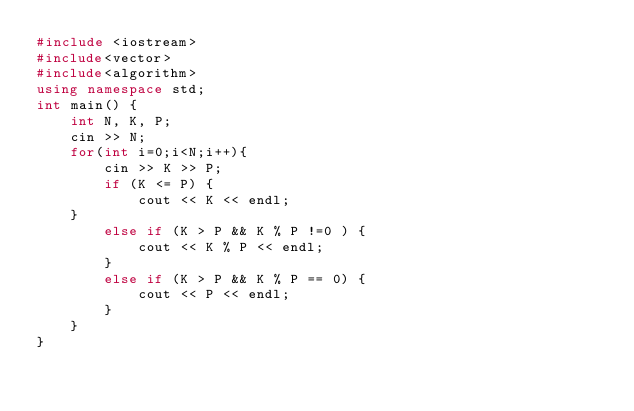Convert code to text. <code><loc_0><loc_0><loc_500><loc_500><_C++_>#include <iostream> 
#include<vector>
#include<algorithm>
using namespace std; 
int main() {
	int N, K, P;
	cin >> N;
	for(int i=0;i<N;i++){
		cin >> K >> P;
		if (K <= P) {
			cout << K << endl;
	}
		else if (K > P && K % P !=0 ) {
			cout << K % P << endl;
		}
		else if (K > P && K % P == 0) {
			cout << P << endl;
		}
	}
}
	
</code> 